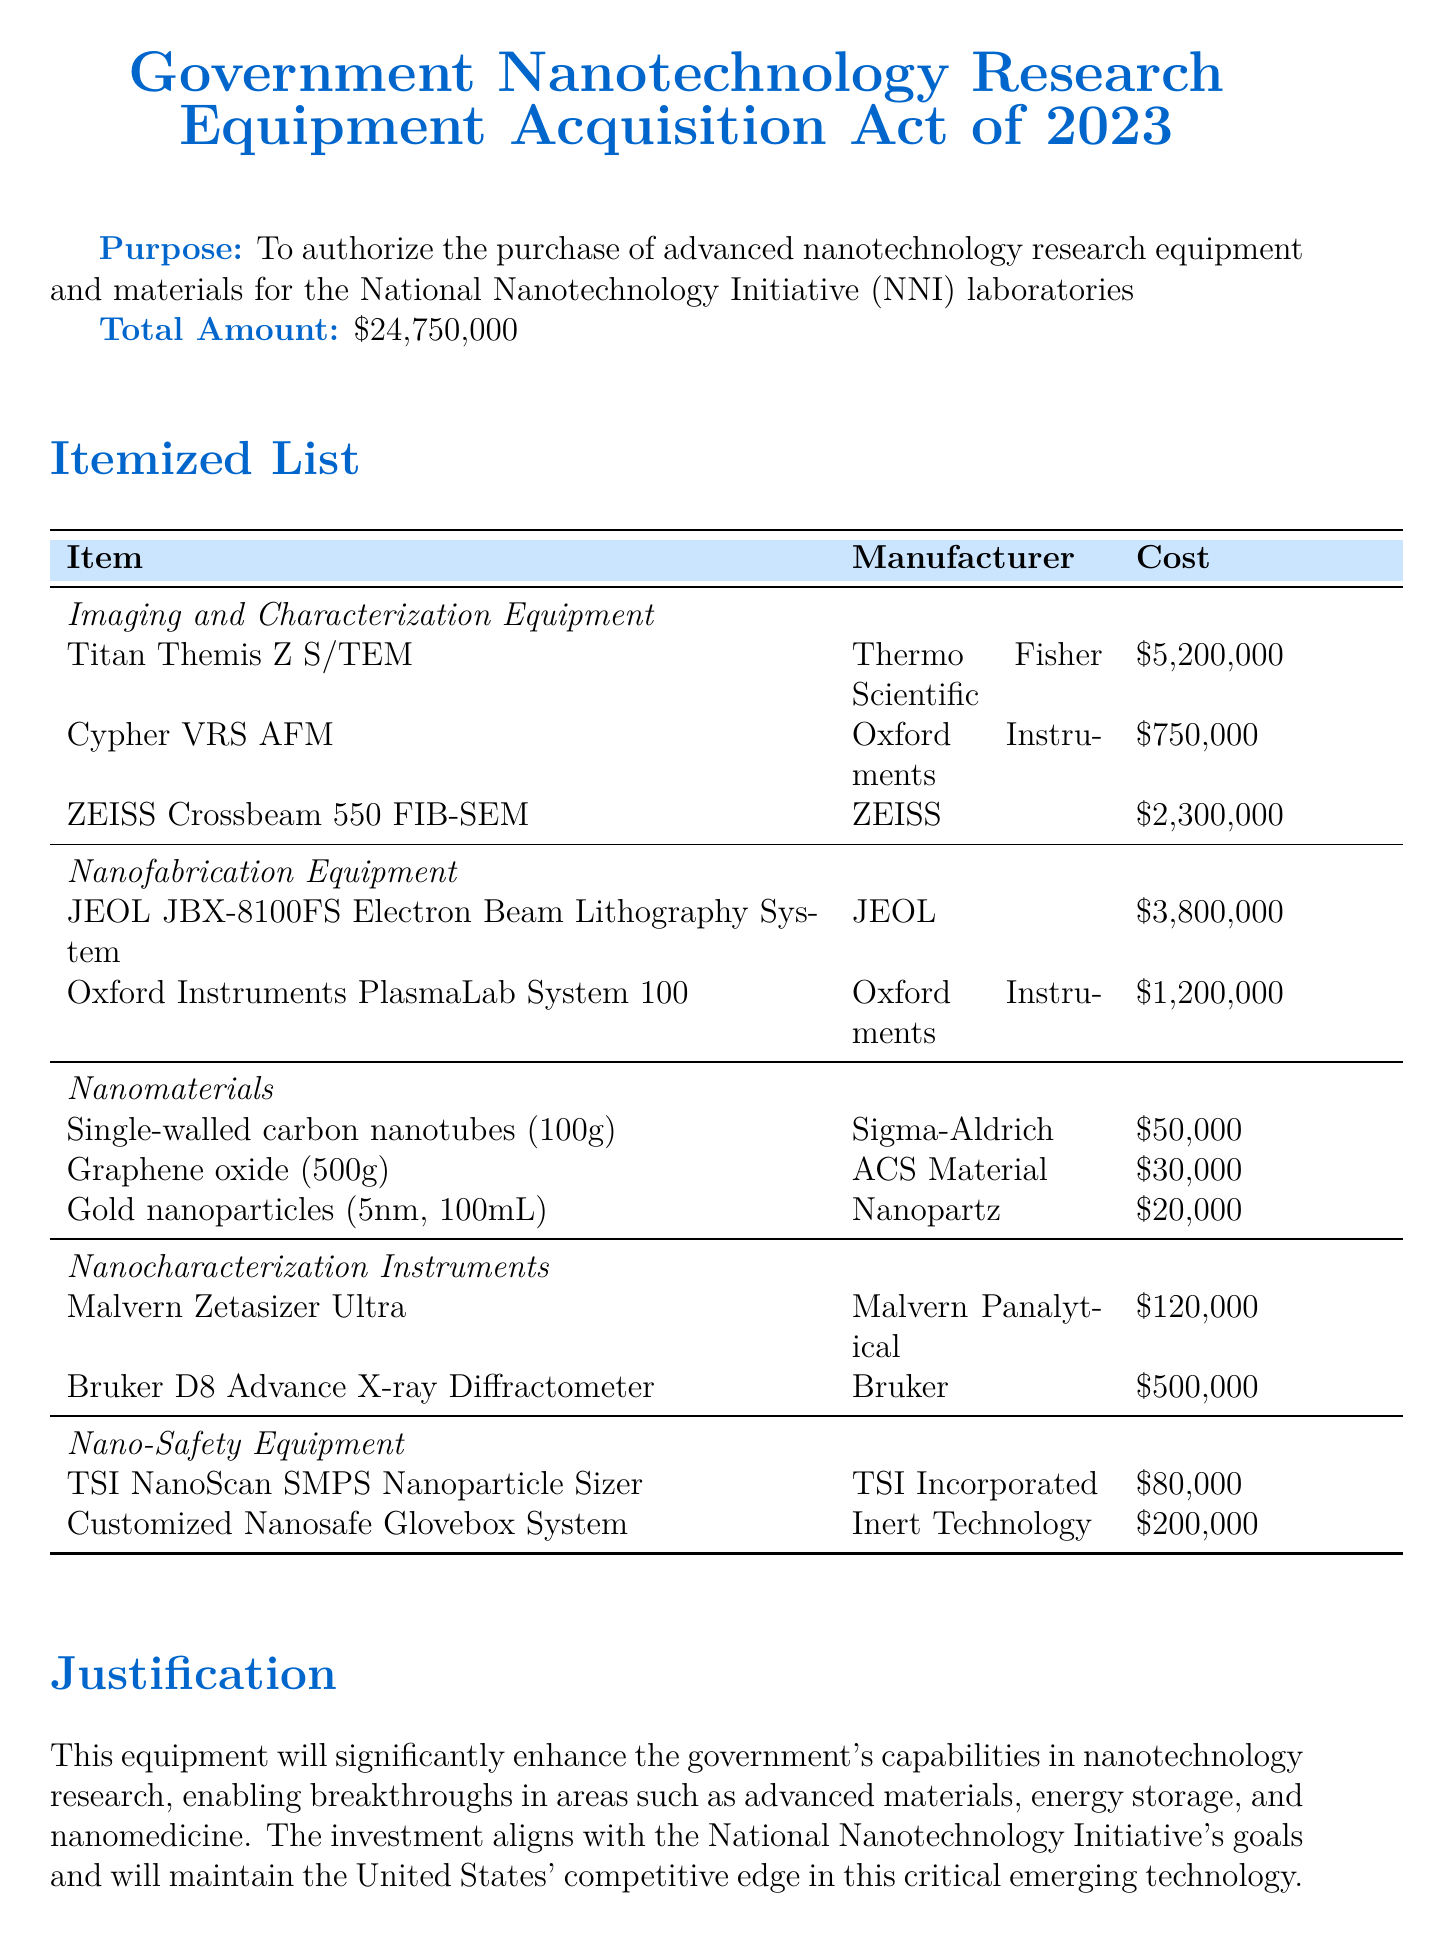what is the title of the bill? The title of the bill is explicitly mentioned at the beginning of the document under the header.
Answer: Government Nanotechnology Research Equipment Acquisition Act of 2023 what is the total amount allocated in the bill? The total amount is stated clearly under the total amount header in the document.
Answer: $24,750,000 who is the responsible agency for this bill? The responsible agency is specified in a separate header within the document.
Answer: National Institute of Standards and Technology (NIST) how many imaging and characterization equipment items are listed? The count is derived from the itemized list of devices under the imaging and characterization equipment category.
Answer: 3 what is the purpose of the Titan Themis Z S/TEM? The purpose of this equipment is provided alongside its listing in the itemized equipment section.
Answer: Atomic-resolution imaging and analysis of nanomaterials what is the expected outcome regarding safety protocols? The expected outcomes are listed succinctly in an itemized format, one of which addresses safety protocols improvements.
Answer: Improved safety protocols for handling and studying nanomaterials who funds the acquisition of the equipment? The funding source is mentioned explicitly in the document under a specific funding header.
Answer: National Science Foundation (NSF) - Advanced Technology Program what type of equipment is the JEOL JBX-8100FS? The type is identified in the itemized list under the nanofabrication equipment category.
Answer: Electron Beam Lithography System which committee oversees this bill? The overseeing committee is indicated under a specific header towards the end of the document.
Answer: House Committee on Science, Space, and Technology 